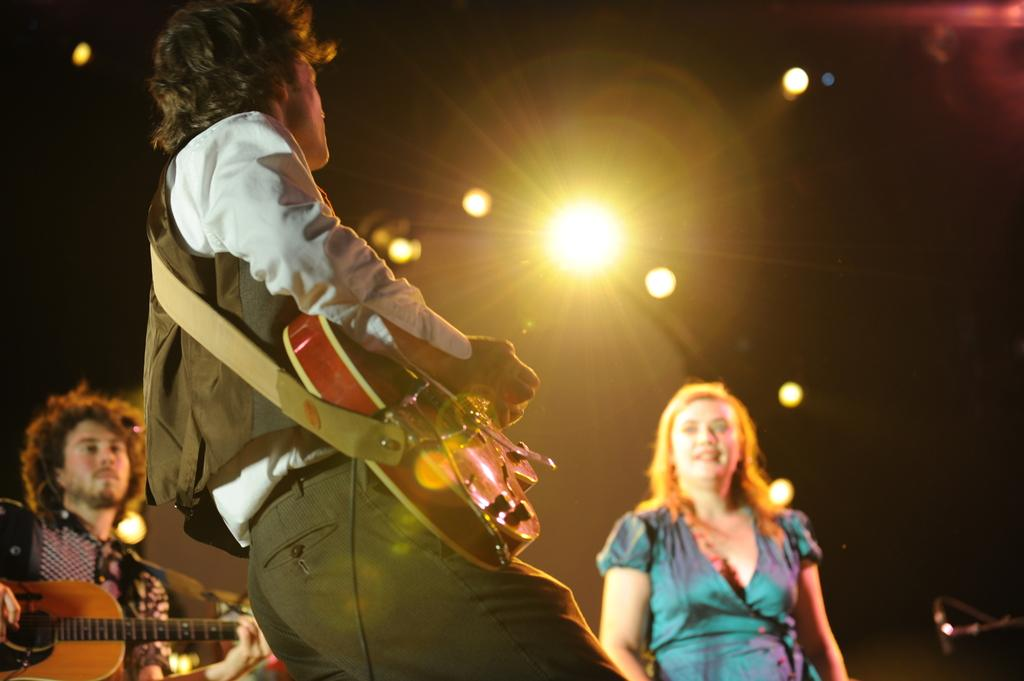How many people are in the image? There are three persons in the image. Where are the persons located in the image? The persons are standing on a stage. What are the persons doing in the image? The persons are playing musical instruments. What can be seen in the background of the image? There are lights visible in the background of the image. What type of cactus can be seen growing on the stage in the image? There is no cactus present in the image; the stage is occupied by the three persons playing musical instruments. 